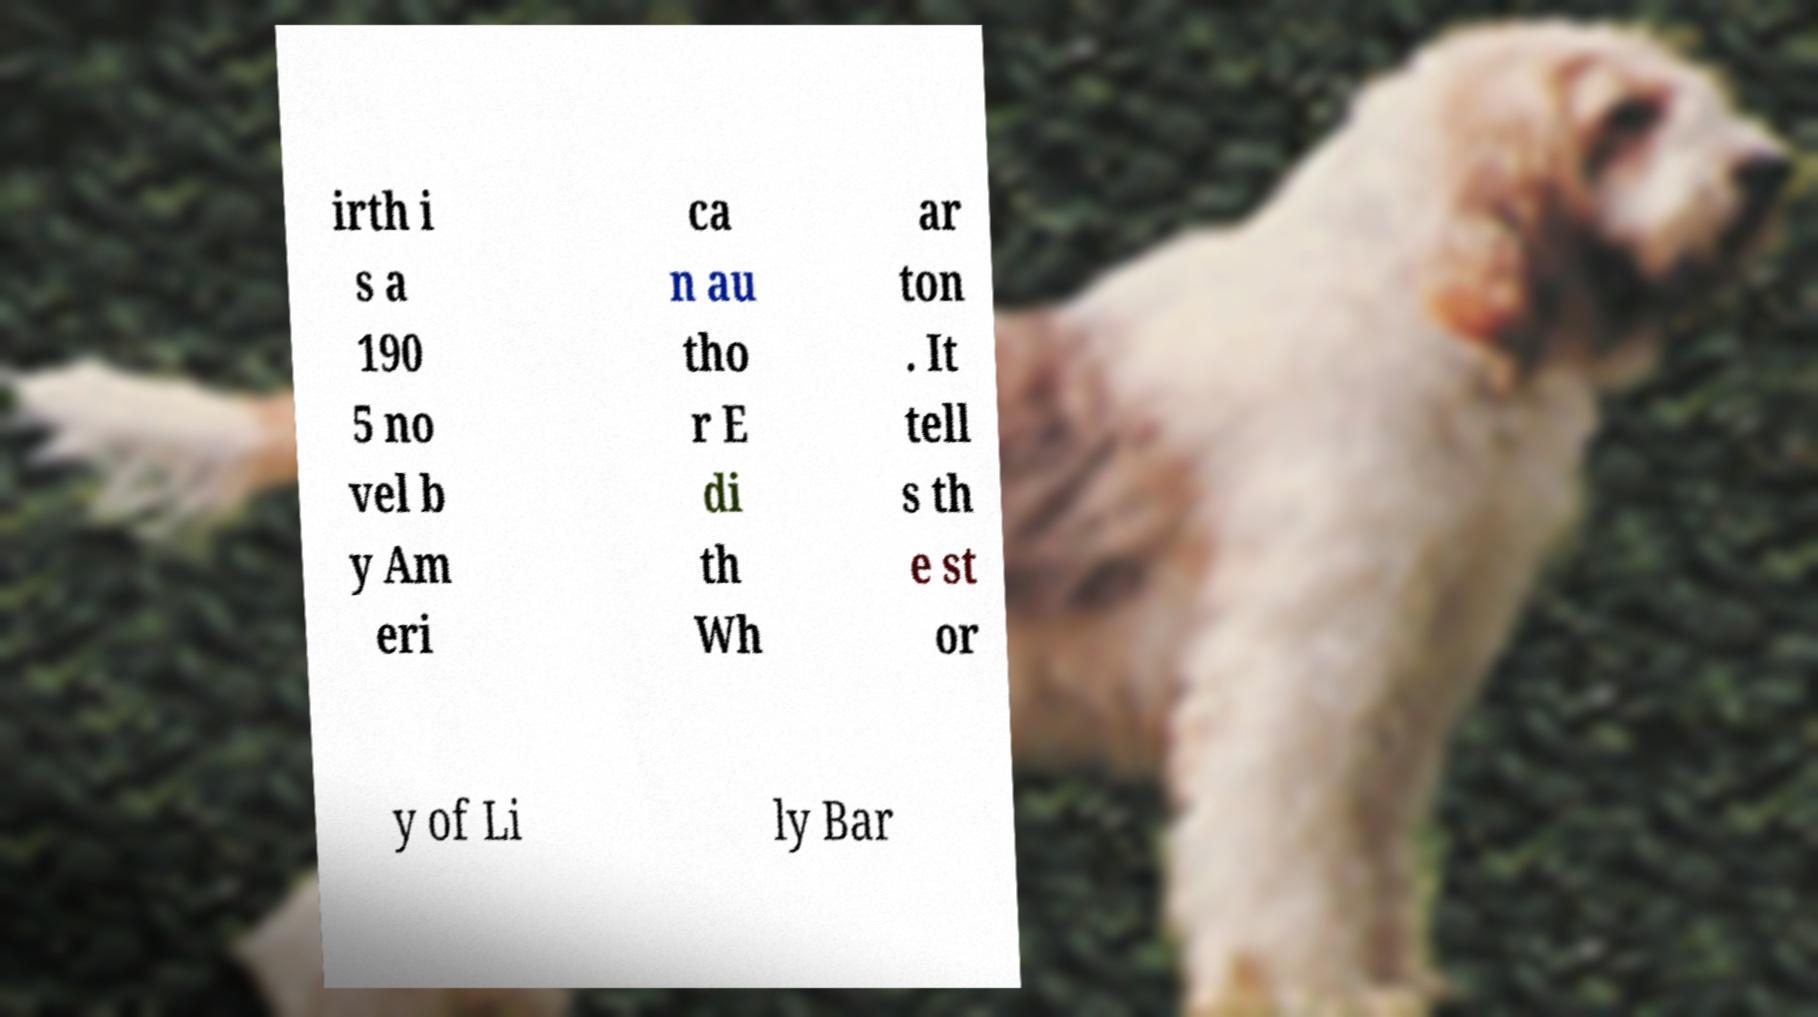For documentation purposes, I need the text within this image transcribed. Could you provide that? irth i s a 190 5 no vel b y Am eri ca n au tho r E di th Wh ar ton . It tell s th e st or y of Li ly Bar 